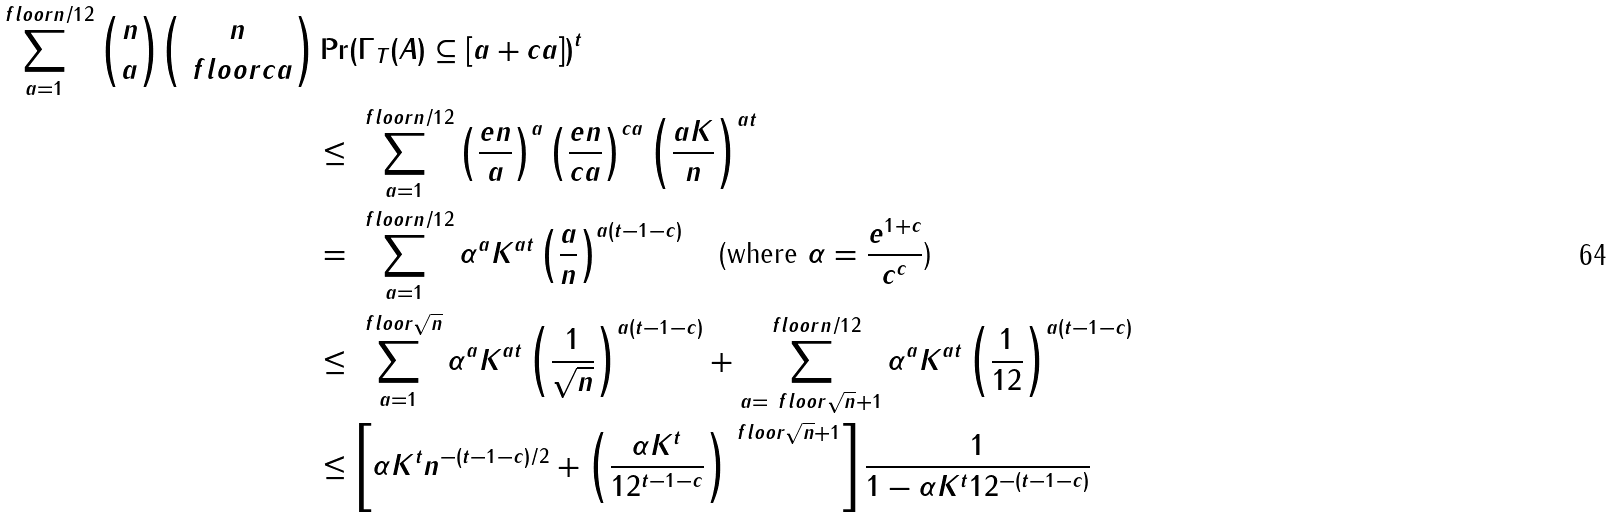<formula> <loc_0><loc_0><loc_500><loc_500>\sum _ { a = 1 } ^ { \ f l o o r { n / 1 2 } } \binom { n } { a } \binom { n } { \ f l o o r { c a } } & \Pr ( \Gamma _ { T } ( A ) \subseteq [ a + c a ] ) ^ { t } \\ & \leq \sum _ { a = 1 } ^ { \ f l o o r { n / 1 2 } } \left ( \frac { e n } { a } \right ) ^ { a } \left ( \frac { e n } { c a } \right ) ^ { c a } \left ( \frac { a K } { n } \right ) ^ { a t } \\ & = \sum _ { a = 1 } ^ { \ f l o o r { n / 1 2 } } \alpha ^ { a } K ^ { a t } \left ( \frac { a } { n } \right ) ^ { a ( t - 1 - c ) } \quad \text {(where $\alpha = \frac{e^{1+c}}{c^{c}}$)} \\ & \leq \sum _ { a = 1 } ^ { \ f l o o r { \sqrt { n } } } \alpha ^ { a } K ^ { a t } \left ( \frac { 1 } { \sqrt { n } } \right ) ^ { a ( t - 1 - c ) } + \sum _ { a = \ f l o o r { \sqrt { n } } + 1 } ^ { \ f l o o r { n / 1 2 } } \alpha ^ { a } K ^ { a t } \left ( \frac { 1 } { 1 2 } \right ) ^ { a ( t - 1 - c ) } \\ & \leq \left [ \alpha K ^ { t } n ^ { - ( t - 1 - c ) / 2 } + \left ( \frac { \alpha K ^ { t } } { 1 2 ^ { t - 1 - c } } \right ) ^ { \ f l o o r { \sqrt { n } } + 1 } \right ] \frac { 1 } { 1 - \alpha K ^ { t } 1 2 ^ { - ( t - 1 - c ) } }</formula> 